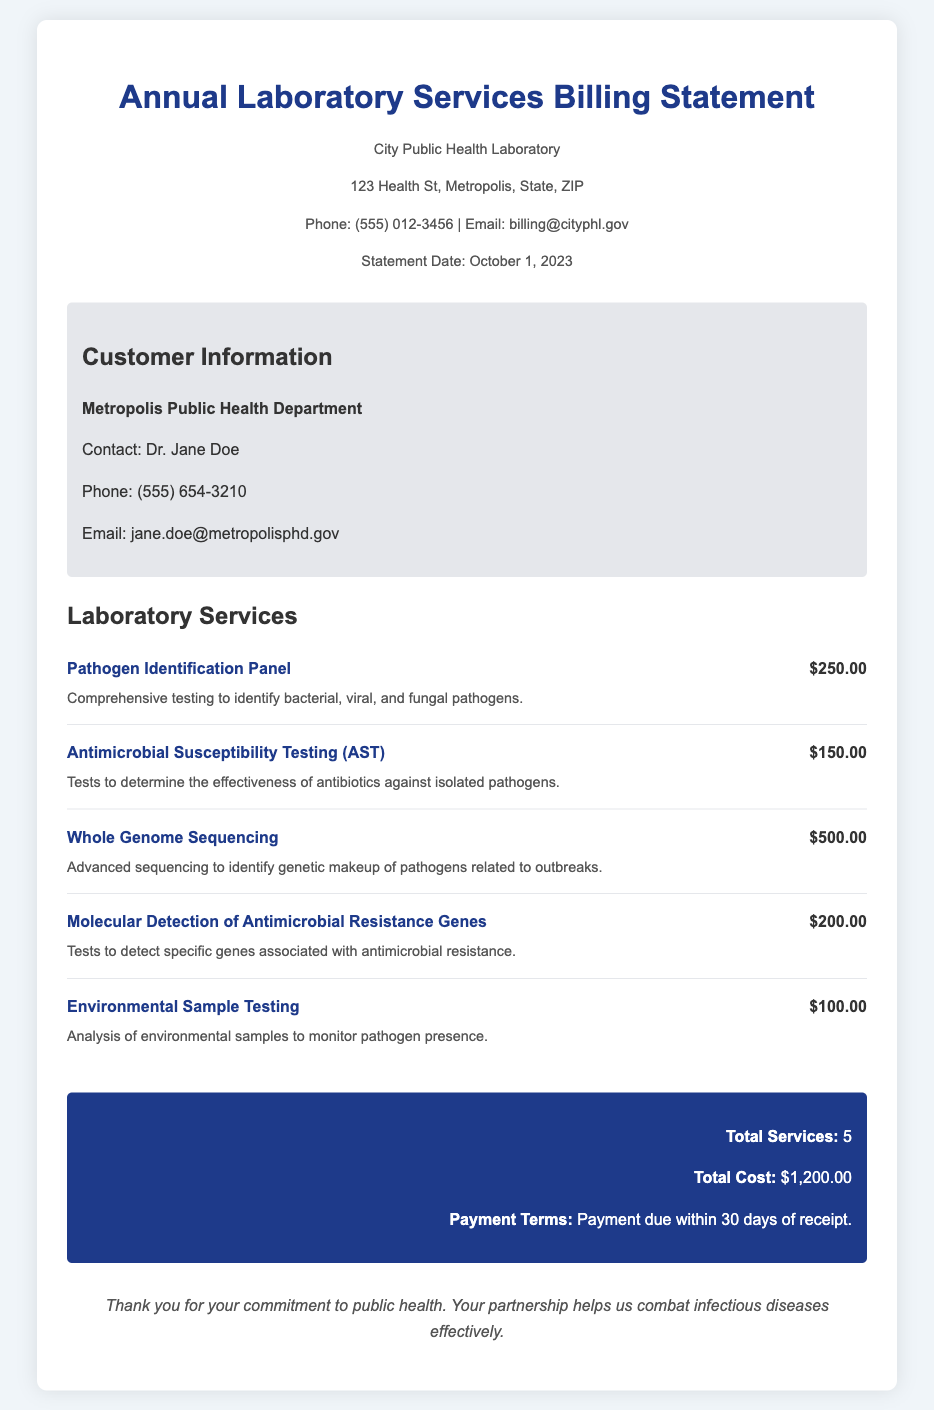What is the title of the document? The title of the document is prominently displayed at the top of the billing statement.
Answer: Annual Laboratory Services Billing Statement What is the date of the statement? The statement date is mentioned in the organization information section.
Answer: October 1, 2023 Who is the contact person for the customer? The customer's contact person is listed in the customer information section.
Answer: Dr. Jane Doe How much does the Pathogen Identification Panel cost? The cost of the Pathogen Identification Panel is specified in the services section.
Answer: $250.00 What is the total cost for all services listed? The total cost is calculated based on the individual service costs and is shown in the summary.
Answer: $1,200.00 What kind of testing does the Environmental Sample Testing service provide? The description of the Environmental Sample Testing service explains its purpose.
Answer: Analysis of environmental samples to monitor pathogen presence How many different services are included in the billing statement? The total number of services provided is summarized at the bottom of the document.
Answer: 5 What is the payment term stated in the document? The payment terms are noted in the summary section of the document.
Answer: Payment due within 30 days of receipt 